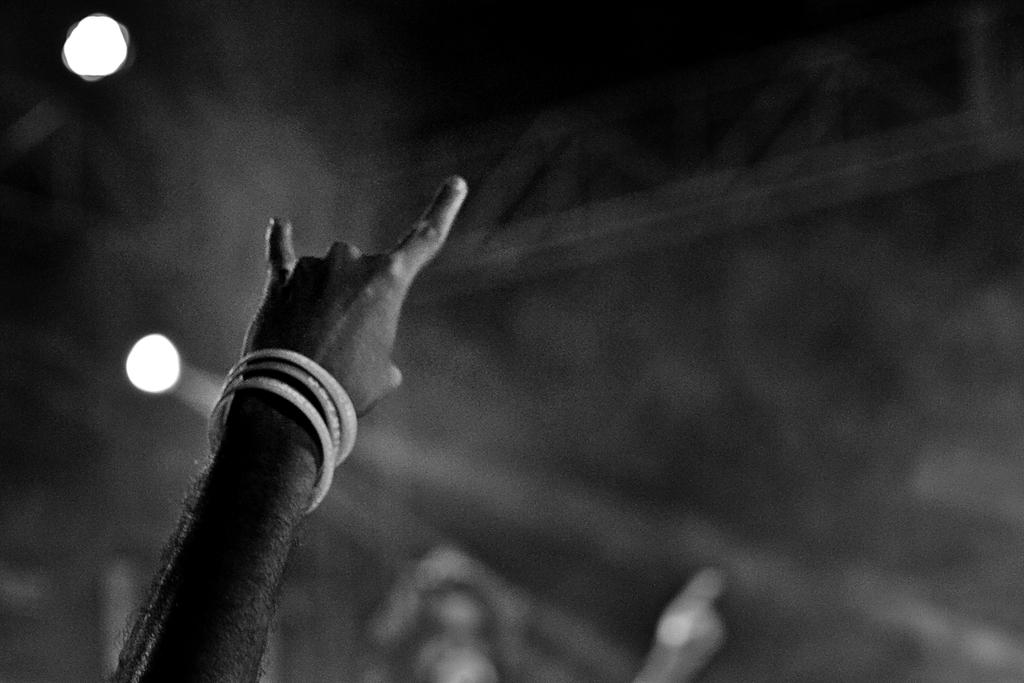What can be seen at the bottom of the image? There is a hand at the bottom of the image. What is present at the top of the image? There are lights at the top of the image. Can you describe the breath of the hand in the image? There is no breath associated with the hand in the image, as it is a static representation. What type of stem is connected to the lights in the image? There is no stem connected to the lights in the image; they are simply depicted at the top. 